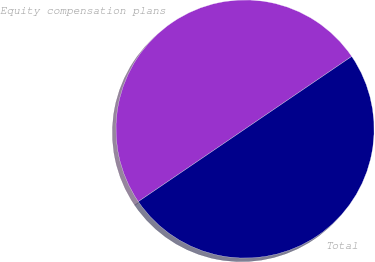<chart> <loc_0><loc_0><loc_500><loc_500><pie_chart><fcel>Equity compensation plans<fcel>Total<nl><fcel>50.0%<fcel>50.0%<nl></chart> 